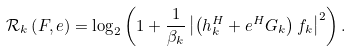Convert formula to latex. <formula><loc_0><loc_0><loc_500><loc_500>& \mathcal { R } _ { k } \left ( F , e \right ) = \log _ { 2 } \left ( 1 + \frac { 1 } { \beta _ { k } } \left | \left ( h _ { k } ^ { H } + e ^ { H } G _ { k } \right ) { f } _ { k } \right | ^ { 2 } \right ) .</formula> 